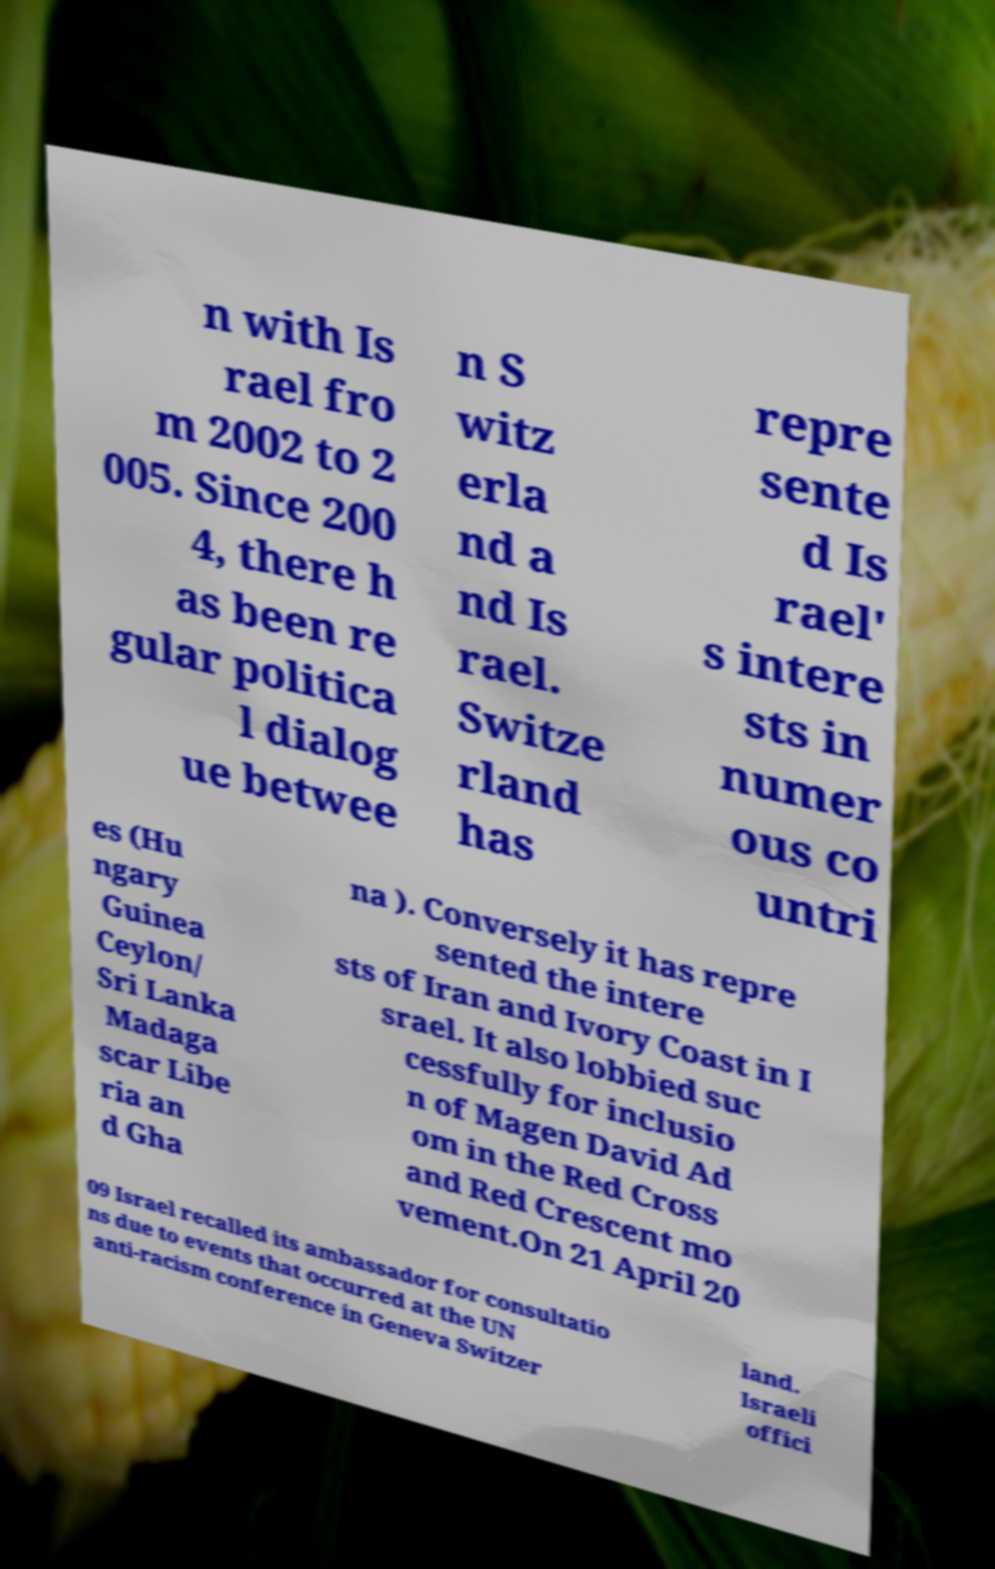Can you accurately transcribe the text from the provided image for me? n with Is rael fro m 2002 to 2 005. Since 200 4, there h as been re gular politica l dialog ue betwee n S witz erla nd a nd Is rael. Switze rland has repre sente d Is rael' s intere sts in numer ous co untri es (Hu ngary Guinea Ceylon/ Sri Lanka Madaga scar Libe ria an d Gha na ). Conversely it has repre sented the intere sts of Iran and Ivory Coast in I srael. It also lobbied suc cessfully for inclusio n of Magen David Ad om in the Red Cross and Red Crescent mo vement.On 21 April 20 09 Israel recalled its ambassador for consultatio ns due to events that occurred at the UN anti-racism conference in Geneva Switzer land. Israeli offici 